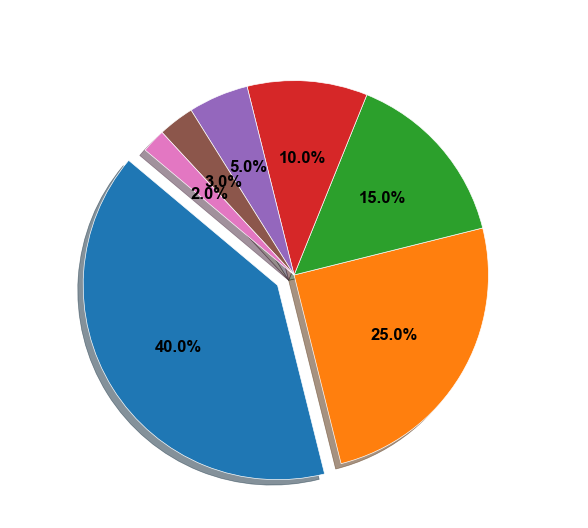Which platform is used by the most metal fans? The pie chart shows the proportion of music streaming platforms used by metal fans. The segment for Spotify is the largest.
Answer: Spotify What's the combined proportion of Amazon Music and Tidal users? To find the combined proportion, add the proportions of Amazon Music (10) and Tidal (5). 10 + 5 = 15.
Answer: 15% Which platform is used least by metal fans? The segment labeled "Others" is the smallest in the pie chart.
Answer: Others Is the proportion of Spotify users greater than the combined proportion of Apple Music and YouTube Music users? Add the proportions of Apple Music (25) and YouTube Music (15). The sum is 40, which is equal to Spotify's proportion (40).
Answer: No By how much does Spotify's proportion exceed Amazon Music's proportion? Subtract the proportion of Amazon Music (10) from the proportion of Spotify (40). 40 - 10 = 30.
Answer: 30% If you combined all non-Spotify platforms, would the combined proportion be greater than or less than Spotify alone? Sum the proportions of Apple Music (25), YouTube Music (15), Amazon Music (10), Tidal (5), Bandcamp (3), and Others (2). The sum is 60. Since 60 is greater than Spotify's 40.
Answer: Greater Which platform comes third in popularity among metal fans? The third largest segment after Spotify and Apple Music is YouTube Music.
Answer: YouTube Music What's the difference in proportion between Apple Music and Bandcamp users? Subtract the proportion of Bandcamp (3) from Apple Music (25). 25 - 3 = 22.
Answer: 22% What is the total proportion of users of platforms other than Spotify? Sum the proportions of Apple Music (25), YouTube Music (15), Amazon Music (10), Tidal (5), Bandcamp (3), and Others (2). The total is 60.
Answer: 60% Does the segment with the smallest proportion use lighter or darker color compared to Spotify's segment? The pie chart uses colors, and the segment for "Others," which has the smallest proportion, is lighter compared to the darker blue of Spotify.
Answer: Lighter 